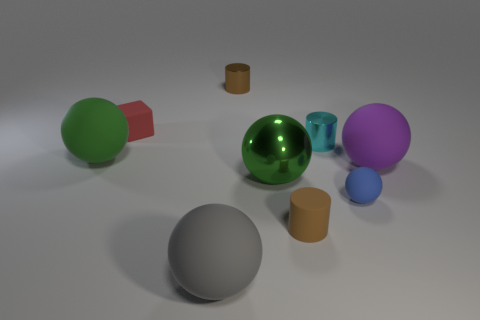What is the size of the matte sphere that is the same color as the large metal object?
Your response must be concise. Large. How many cylinders have the same material as the purple ball?
Provide a short and direct response. 1. What is the size of the matte ball in front of the brown cylinder in front of the cyan metallic cylinder?
Ensure brevity in your answer.  Large. Is there a small cyan metallic object of the same shape as the brown matte thing?
Give a very brief answer. Yes. There is a cylinder that is right of the brown matte cylinder; does it have the same size as the cylinder that is in front of the purple thing?
Keep it short and to the point. Yes. Are there fewer big green rubber spheres that are right of the block than matte balls in front of the green matte ball?
Provide a short and direct response. Yes. What is the material of the ball that is the same color as the big metallic object?
Offer a very short reply. Rubber. There is a large matte sphere to the right of the large green metallic ball; what color is it?
Your answer should be very brief. Purple. What number of rubber things are left of the rubber thing that is in front of the brown cylinder that is in front of the blue matte object?
Offer a very short reply. 2. The matte cylinder is what size?
Make the answer very short. Small. 